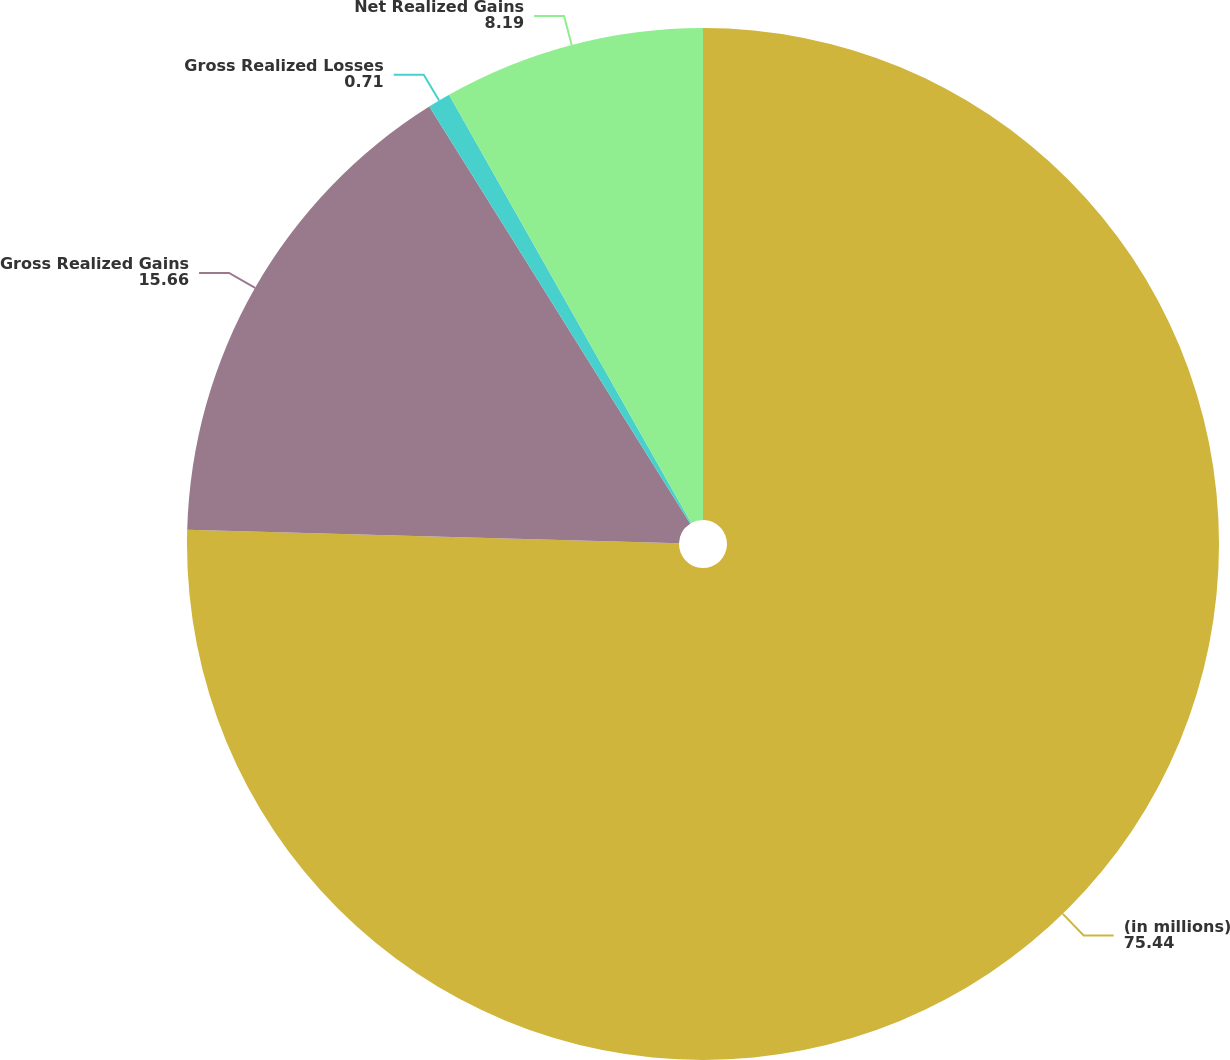Convert chart to OTSL. <chart><loc_0><loc_0><loc_500><loc_500><pie_chart><fcel>(in millions)<fcel>Gross Realized Gains<fcel>Gross Realized Losses<fcel>Net Realized Gains<nl><fcel>75.44%<fcel>15.66%<fcel>0.71%<fcel>8.19%<nl></chart> 